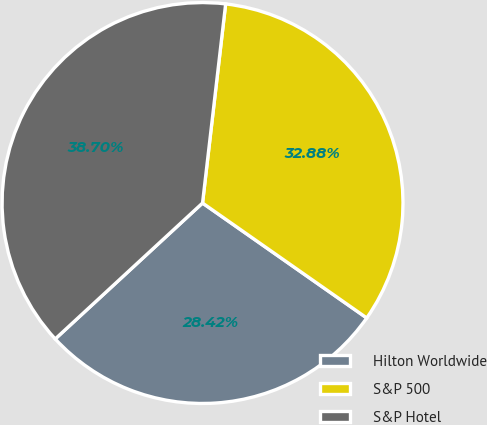<chart> <loc_0><loc_0><loc_500><loc_500><pie_chart><fcel>Hilton Worldwide<fcel>S&P 500<fcel>S&P Hotel<nl><fcel>28.42%<fcel>32.88%<fcel>38.7%<nl></chart> 